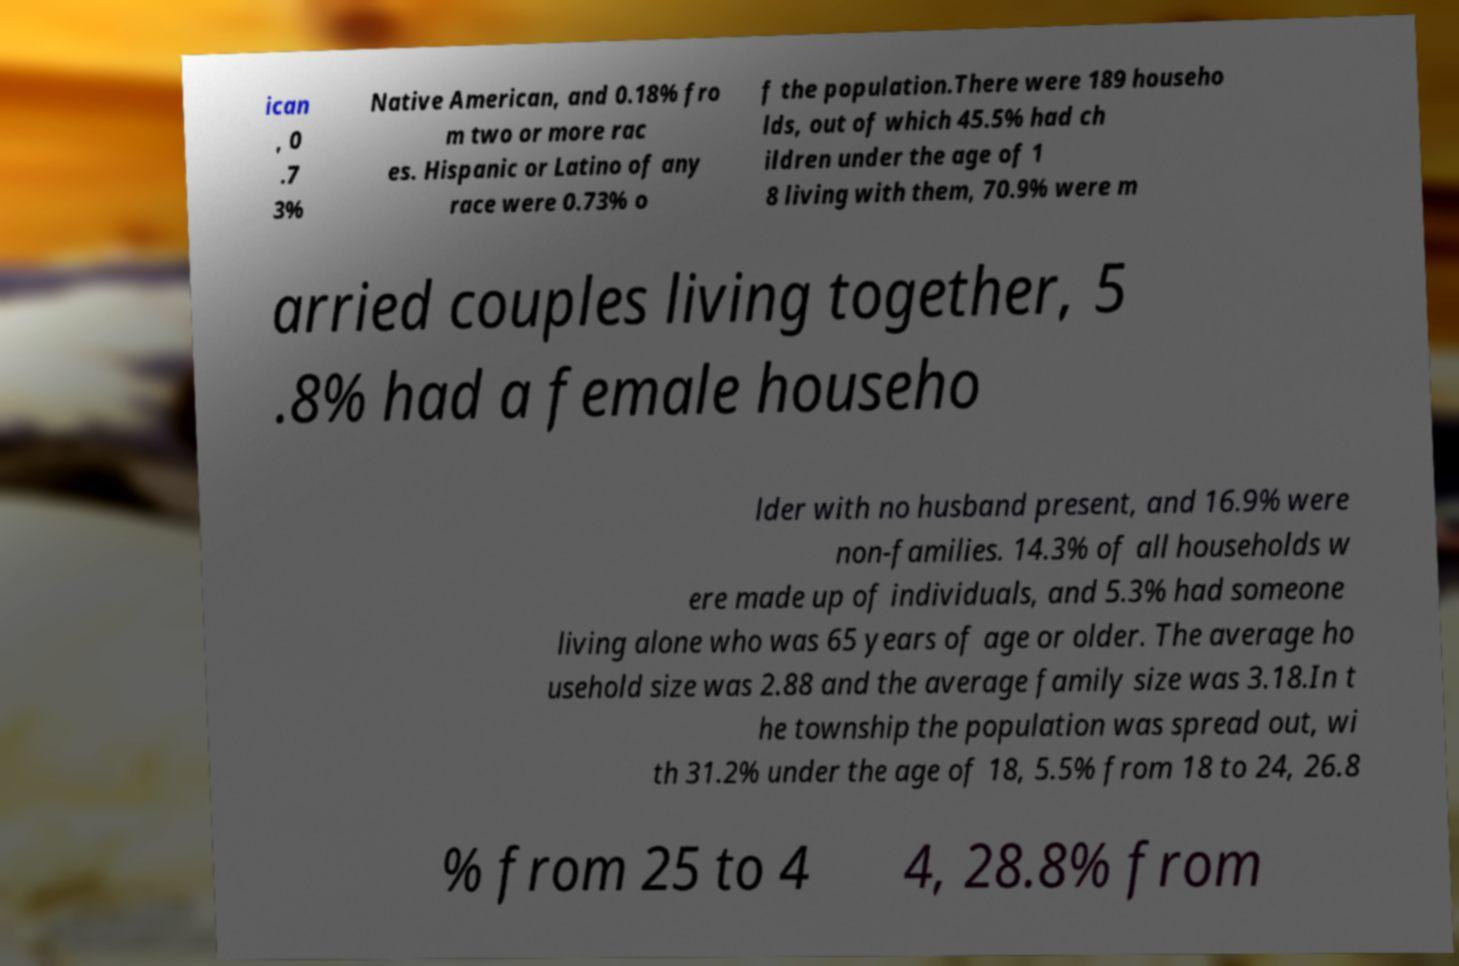For documentation purposes, I need the text within this image transcribed. Could you provide that? ican , 0 .7 3% Native American, and 0.18% fro m two or more rac es. Hispanic or Latino of any race were 0.73% o f the population.There were 189 househo lds, out of which 45.5% had ch ildren under the age of 1 8 living with them, 70.9% were m arried couples living together, 5 .8% had a female househo lder with no husband present, and 16.9% were non-families. 14.3% of all households w ere made up of individuals, and 5.3% had someone living alone who was 65 years of age or older. The average ho usehold size was 2.88 and the average family size was 3.18.In t he township the population was spread out, wi th 31.2% under the age of 18, 5.5% from 18 to 24, 26.8 % from 25 to 4 4, 28.8% from 